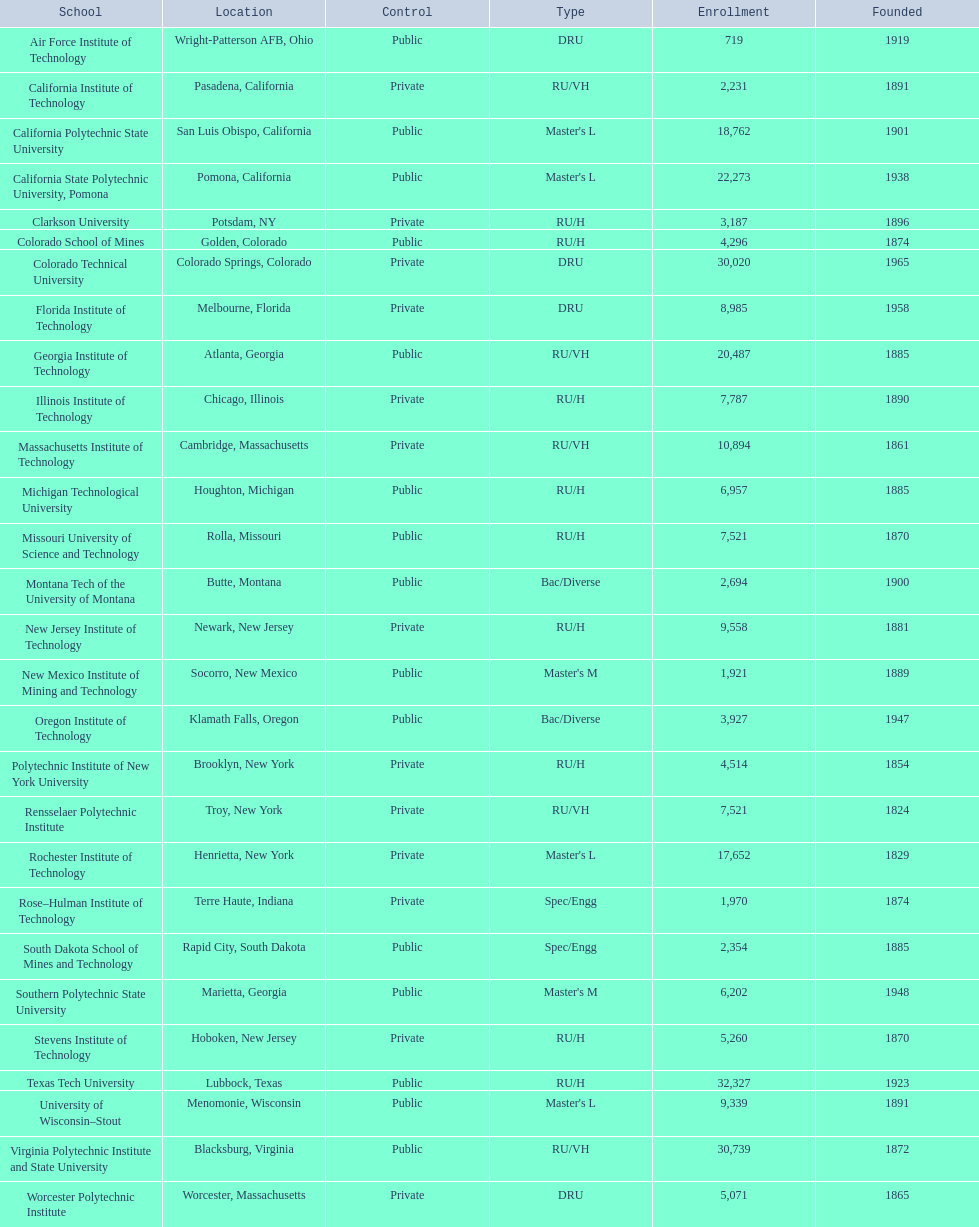What are the names of all the schools? Air Force Institute of Technology, California Institute of Technology, California Polytechnic State University, California State Polytechnic University, Pomona, Clarkson University, Colorado School of Mines, Colorado Technical University, Florida Institute of Technology, Georgia Institute of Technology, Illinois Institute of Technology, Massachusetts Institute of Technology, Michigan Technological University, Missouri University of Science and Technology, Montana Tech of the University of Montana, New Jersey Institute of Technology, New Mexico Institute of Mining and Technology, Oregon Institute of Technology, Polytechnic Institute of New York University, Rensselaer Polytechnic Institute, Rochester Institute of Technology, Rose–Hulman Institute of Technology, South Dakota School of Mines and Technology, Southern Polytechnic State University, Stevens Institute of Technology, Texas Tech University, University of Wisconsin–Stout, Virginia Polytechnic Institute and State University, Worcester Polytechnic Institute. What is the enrollment count for each school? 719, 2,231, 18,762, 22,273, 3,187, 4,296, 30,020, 8,985, 20,487, 7,787, 10,894, 6,957, 7,521, 2,694, 9,558, 1,921, 3,927, 4,514, 7,521, 17,652, 1,970, 2,354, 6,202, 5,260, 32,327, 9,339, 30,739, 5,071. And which school has the highest enrollment? Texas Tech University. 